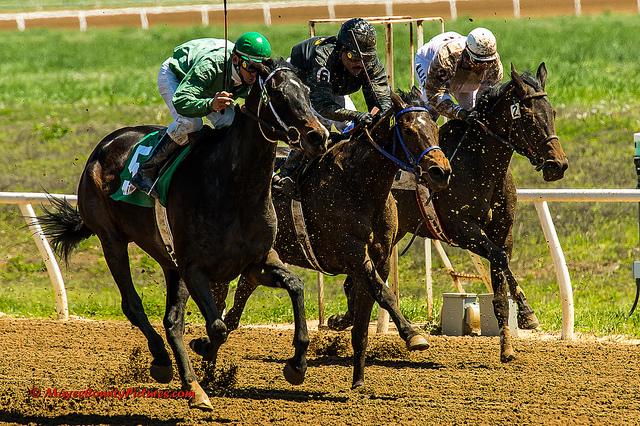What are the jockeys hoping for?
Answer briefly. To win. Are this people racing or horses are running?
Quick response, please. Racing. What sport is she playing?
Be succinct. Horse racing. What preparation has the race track received recently?
Concise answer only. Raked. 